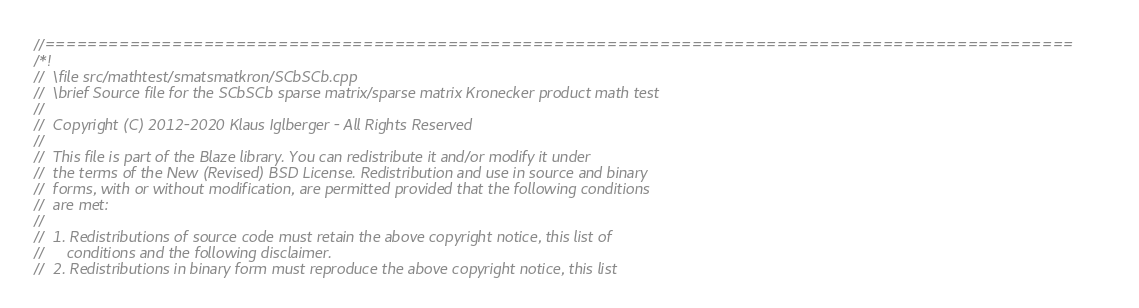<code> <loc_0><loc_0><loc_500><loc_500><_C++_>//=================================================================================================
/*!
//  \file src/mathtest/smatsmatkron/SCbSCb.cpp
//  \brief Source file for the SCbSCb sparse matrix/sparse matrix Kronecker product math test
//
//  Copyright (C) 2012-2020 Klaus Iglberger - All Rights Reserved
//
//  This file is part of the Blaze library. You can redistribute it and/or modify it under
//  the terms of the New (Revised) BSD License. Redistribution and use in source and binary
//  forms, with or without modification, are permitted provided that the following conditions
//  are met:
//
//  1. Redistributions of source code must retain the above copyright notice, this list of
//     conditions and the following disclaimer.
//  2. Redistributions in binary form must reproduce the above copyright notice, this list</code> 